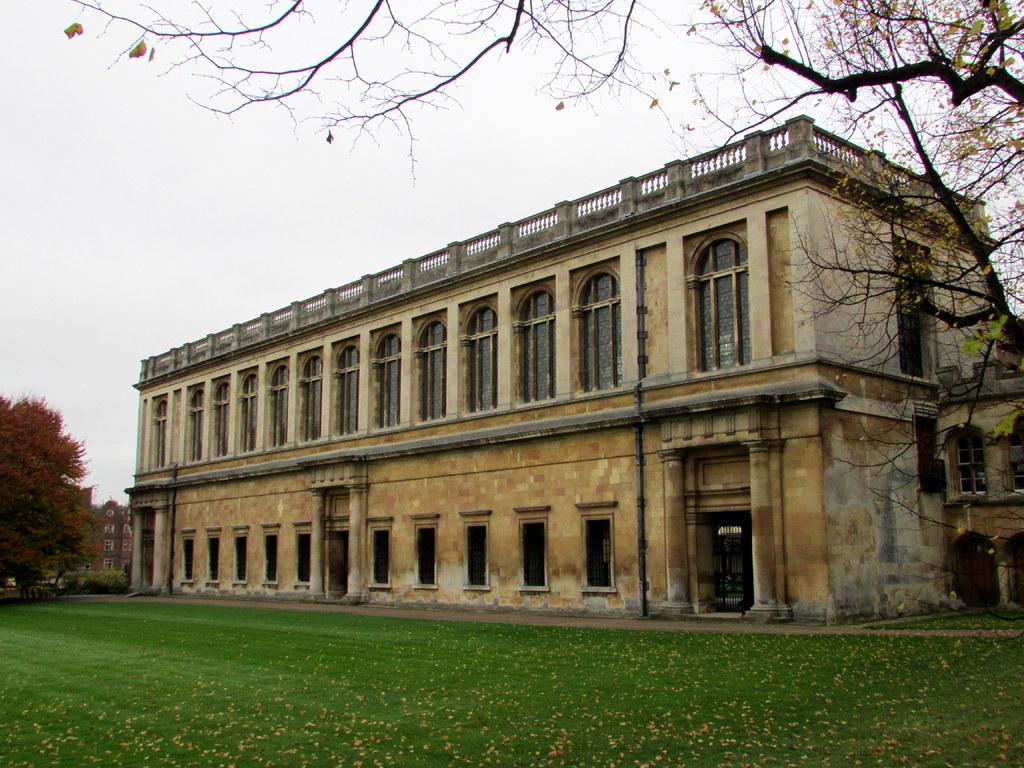What type of structures can be seen in the image? There are buildings in the image. What type of vegetation is at the bottom of the image? There is grass at the bottom of the image. What can be seen in the background of the image? There are trees and the sky visible in the background of the image. What year is depicted in the image? The image does not depict a specific year; it is a static representation of the scene. Can you see a boot in the image? There is no boot present in the image. 